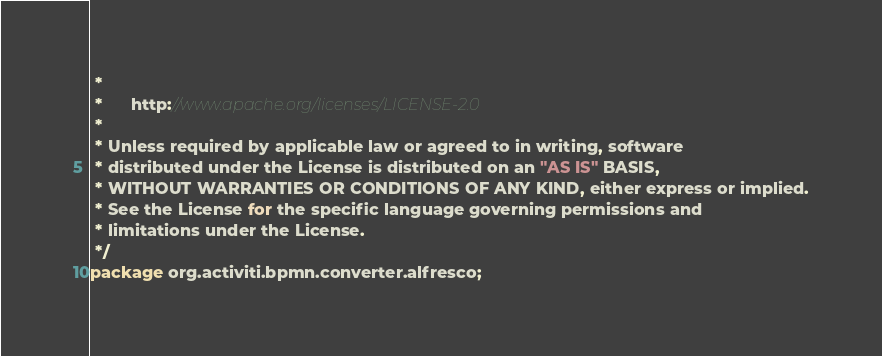<code> <loc_0><loc_0><loc_500><loc_500><_Java_> * 
 *      http://www.apache.org/licenses/LICENSE-2.0
 * 
 * Unless required by applicable law or agreed to in writing, software
 * distributed under the License is distributed on an "AS IS" BASIS,
 * WITHOUT WARRANTIES OR CONDITIONS OF ANY KIND, either express or implied.
 * See the License for the specific language governing permissions and
 * limitations under the License.
 */
package org.activiti.bpmn.converter.alfresco;
</code> 